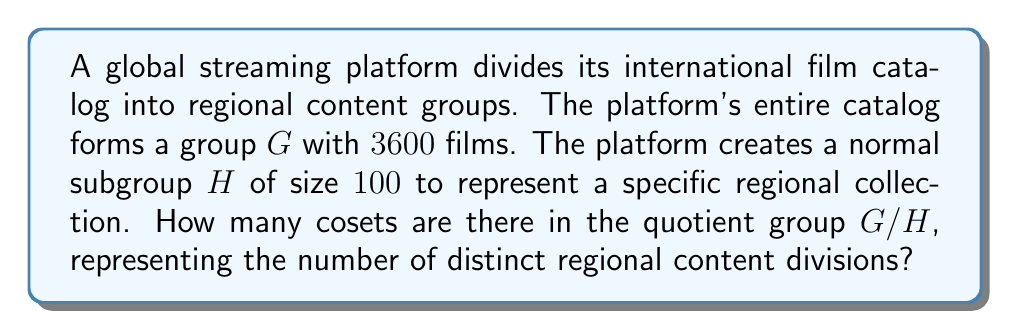Show me your answer to this math problem. To solve this problem, we need to apply the fundamental theorem of cosets and quotient groups. Here's a step-by-step explanation:

1) The quotient group $G/H$ is formed by the cosets of $H$ in $G$.

2) The number of cosets in $G/H$ is equal to the index of $H$ in $G$, denoted as $[G:H]$.

3) The index $[G:H]$ is given by the formula:

   $$[G:H] = \frac{|G|}{|H|}$$

   where $|G|$ is the order (size) of group $G$, and $|H|$ is the order of subgroup $H$.

4) We are given:
   $|G| = 3600$ (total number of films)
   $|H| = 100$ (size of the regional collection subgroup)

5) Substituting these values into the formula:

   $$[G:H] = \frac{|G|}{|H|} = \frac{3600}{100} = 36$$

Therefore, there are 36 cosets in the quotient group $G/H$, representing 36 distinct regional content divisions.
Answer: 36 cosets 